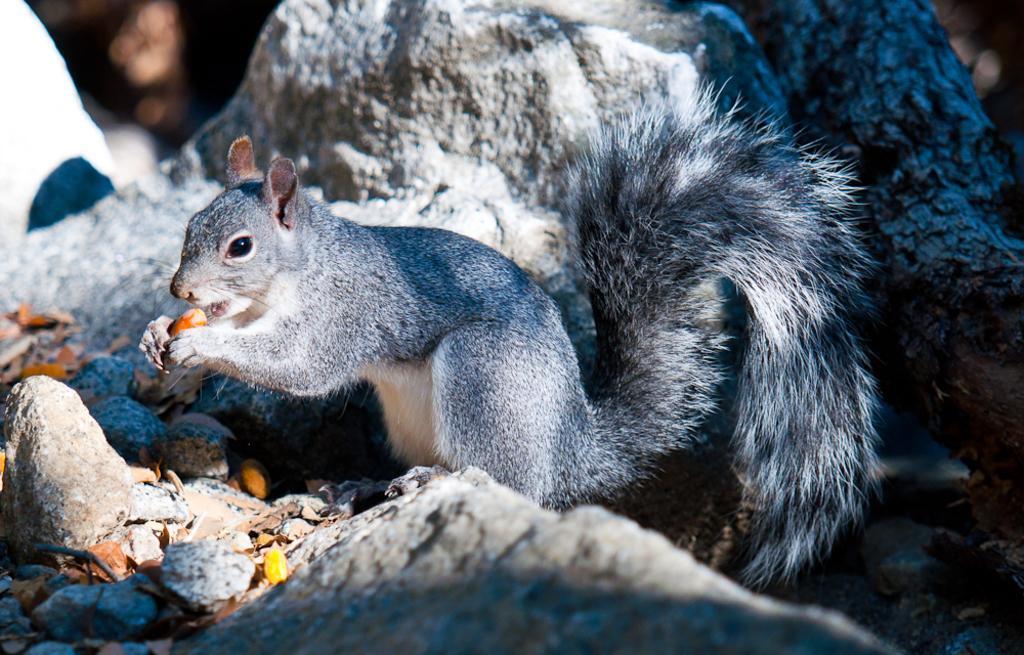In one or two sentences, can you explain what this image depicts? In this image, in the middle, we can see squirrel holding a food item in its hand. In the background, we can see some rocks. At the bottom, we can also see some stones. 